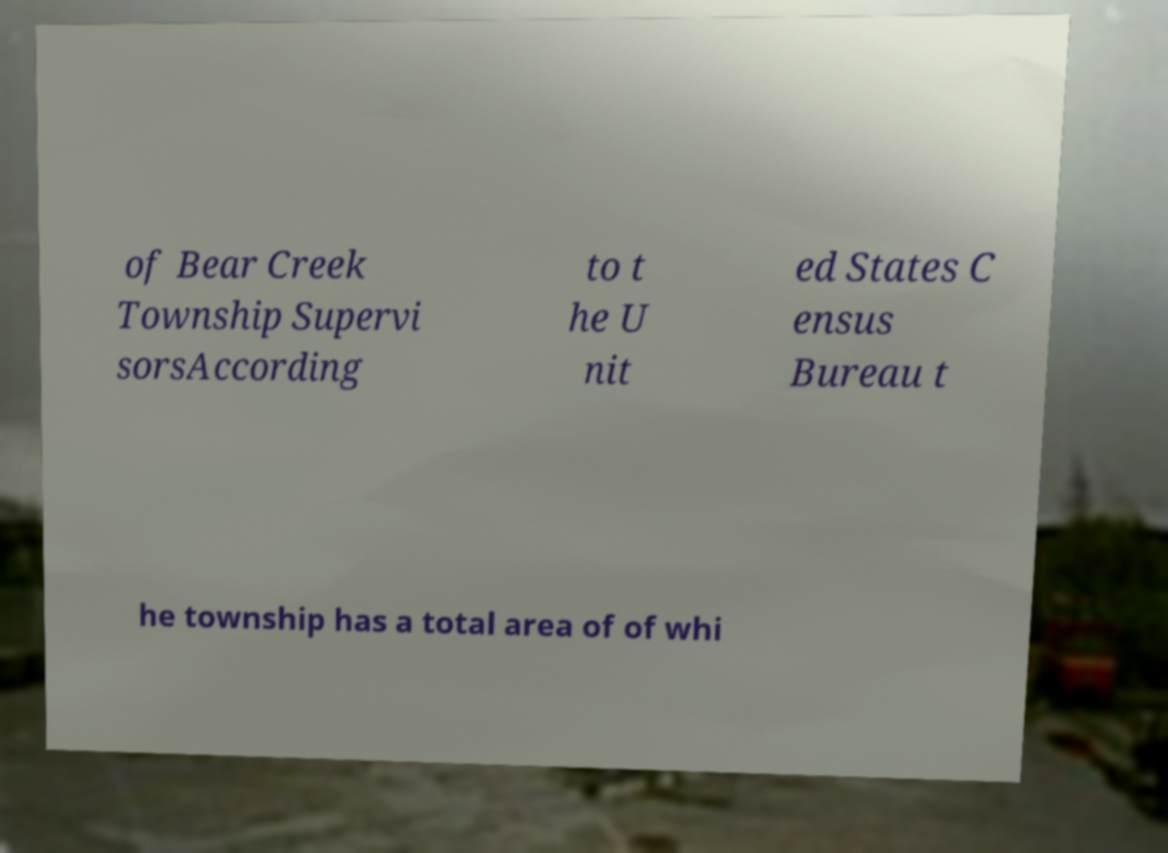Please read and relay the text visible in this image. What does it say? of Bear Creek Township Supervi sorsAccording to t he U nit ed States C ensus Bureau t he township has a total area of of whi 